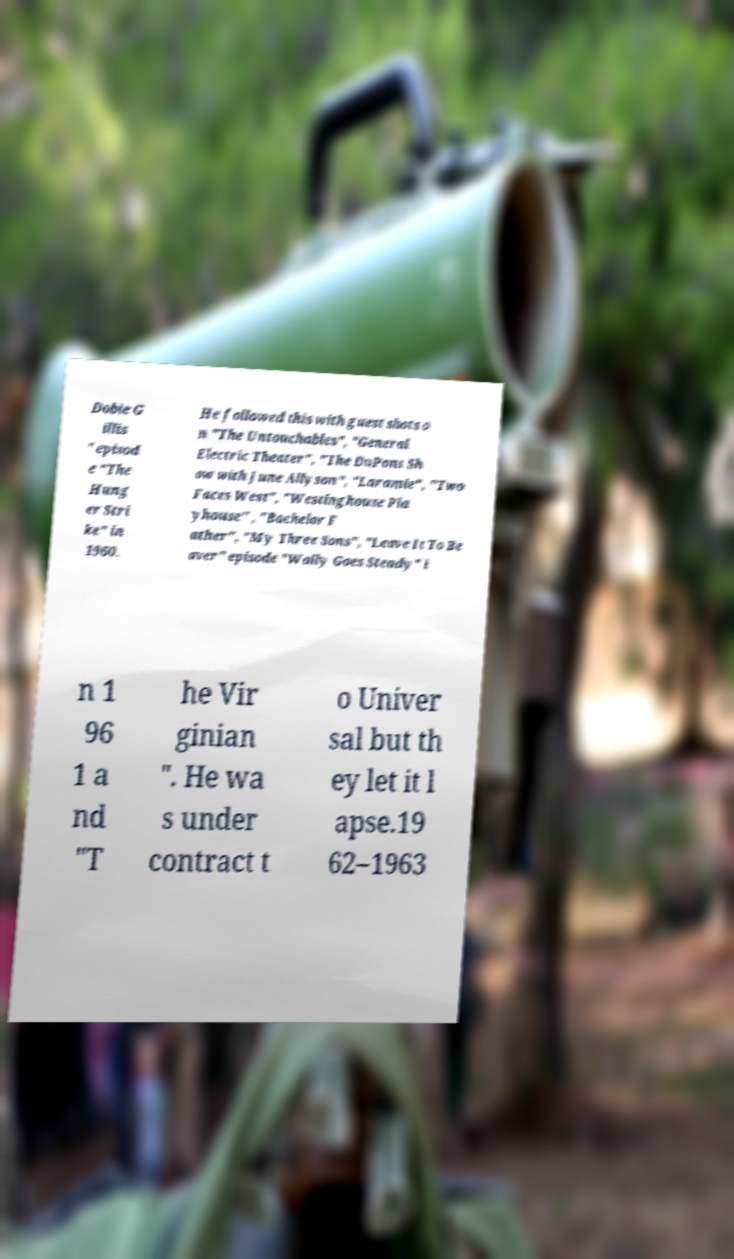For documentation purposes, I need the text within this image transcribed. Could you provide that? Dobie G illis " episod e "The Hung er Stri ke" in 1960. He followed this with guest shots o n "The Untouchables", "General Electric Theater", "The DuPont Sh ow with June Allyson", "Laramie", "Two Faces West", "Westinghouse Pla yhouse" , "Bachelor F ather", "My Three Sons", "Leave It To Be aver" episode "Wally Goes Steady" i n 1 96 1 a nd "T he Vir ginian ". He wa s under contract t o Univer sal but th ey let it l apse.19 62–1963 